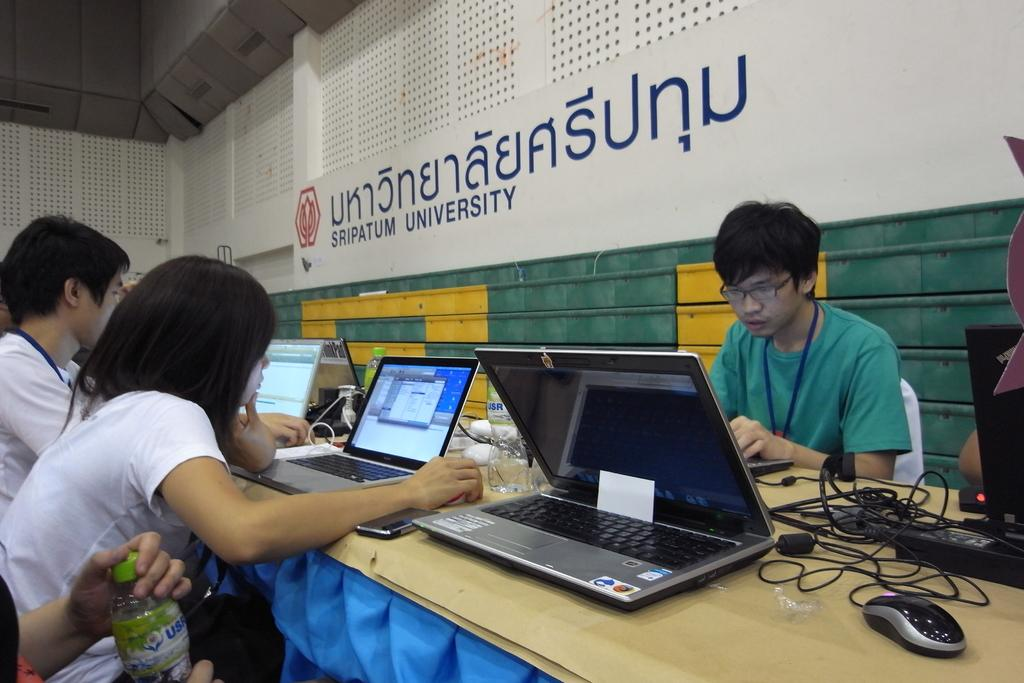<image>
Share a concise interpretation of the image provided. A computer lap inside of Sripatum University, with at least 5 laptops on a big long table 